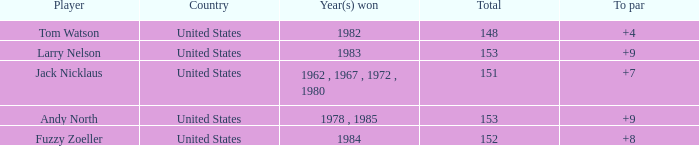What is the Total of the Player with a Year(s) won of 1982? 148.0. 